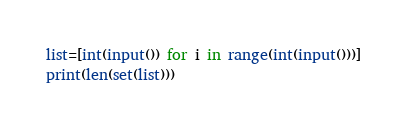<code> <loc_0><loc_0><loc_500><loc_500><_Python_>list=[int(input()) for i in range(int(input()))]
print(len(set(list)))</code> 